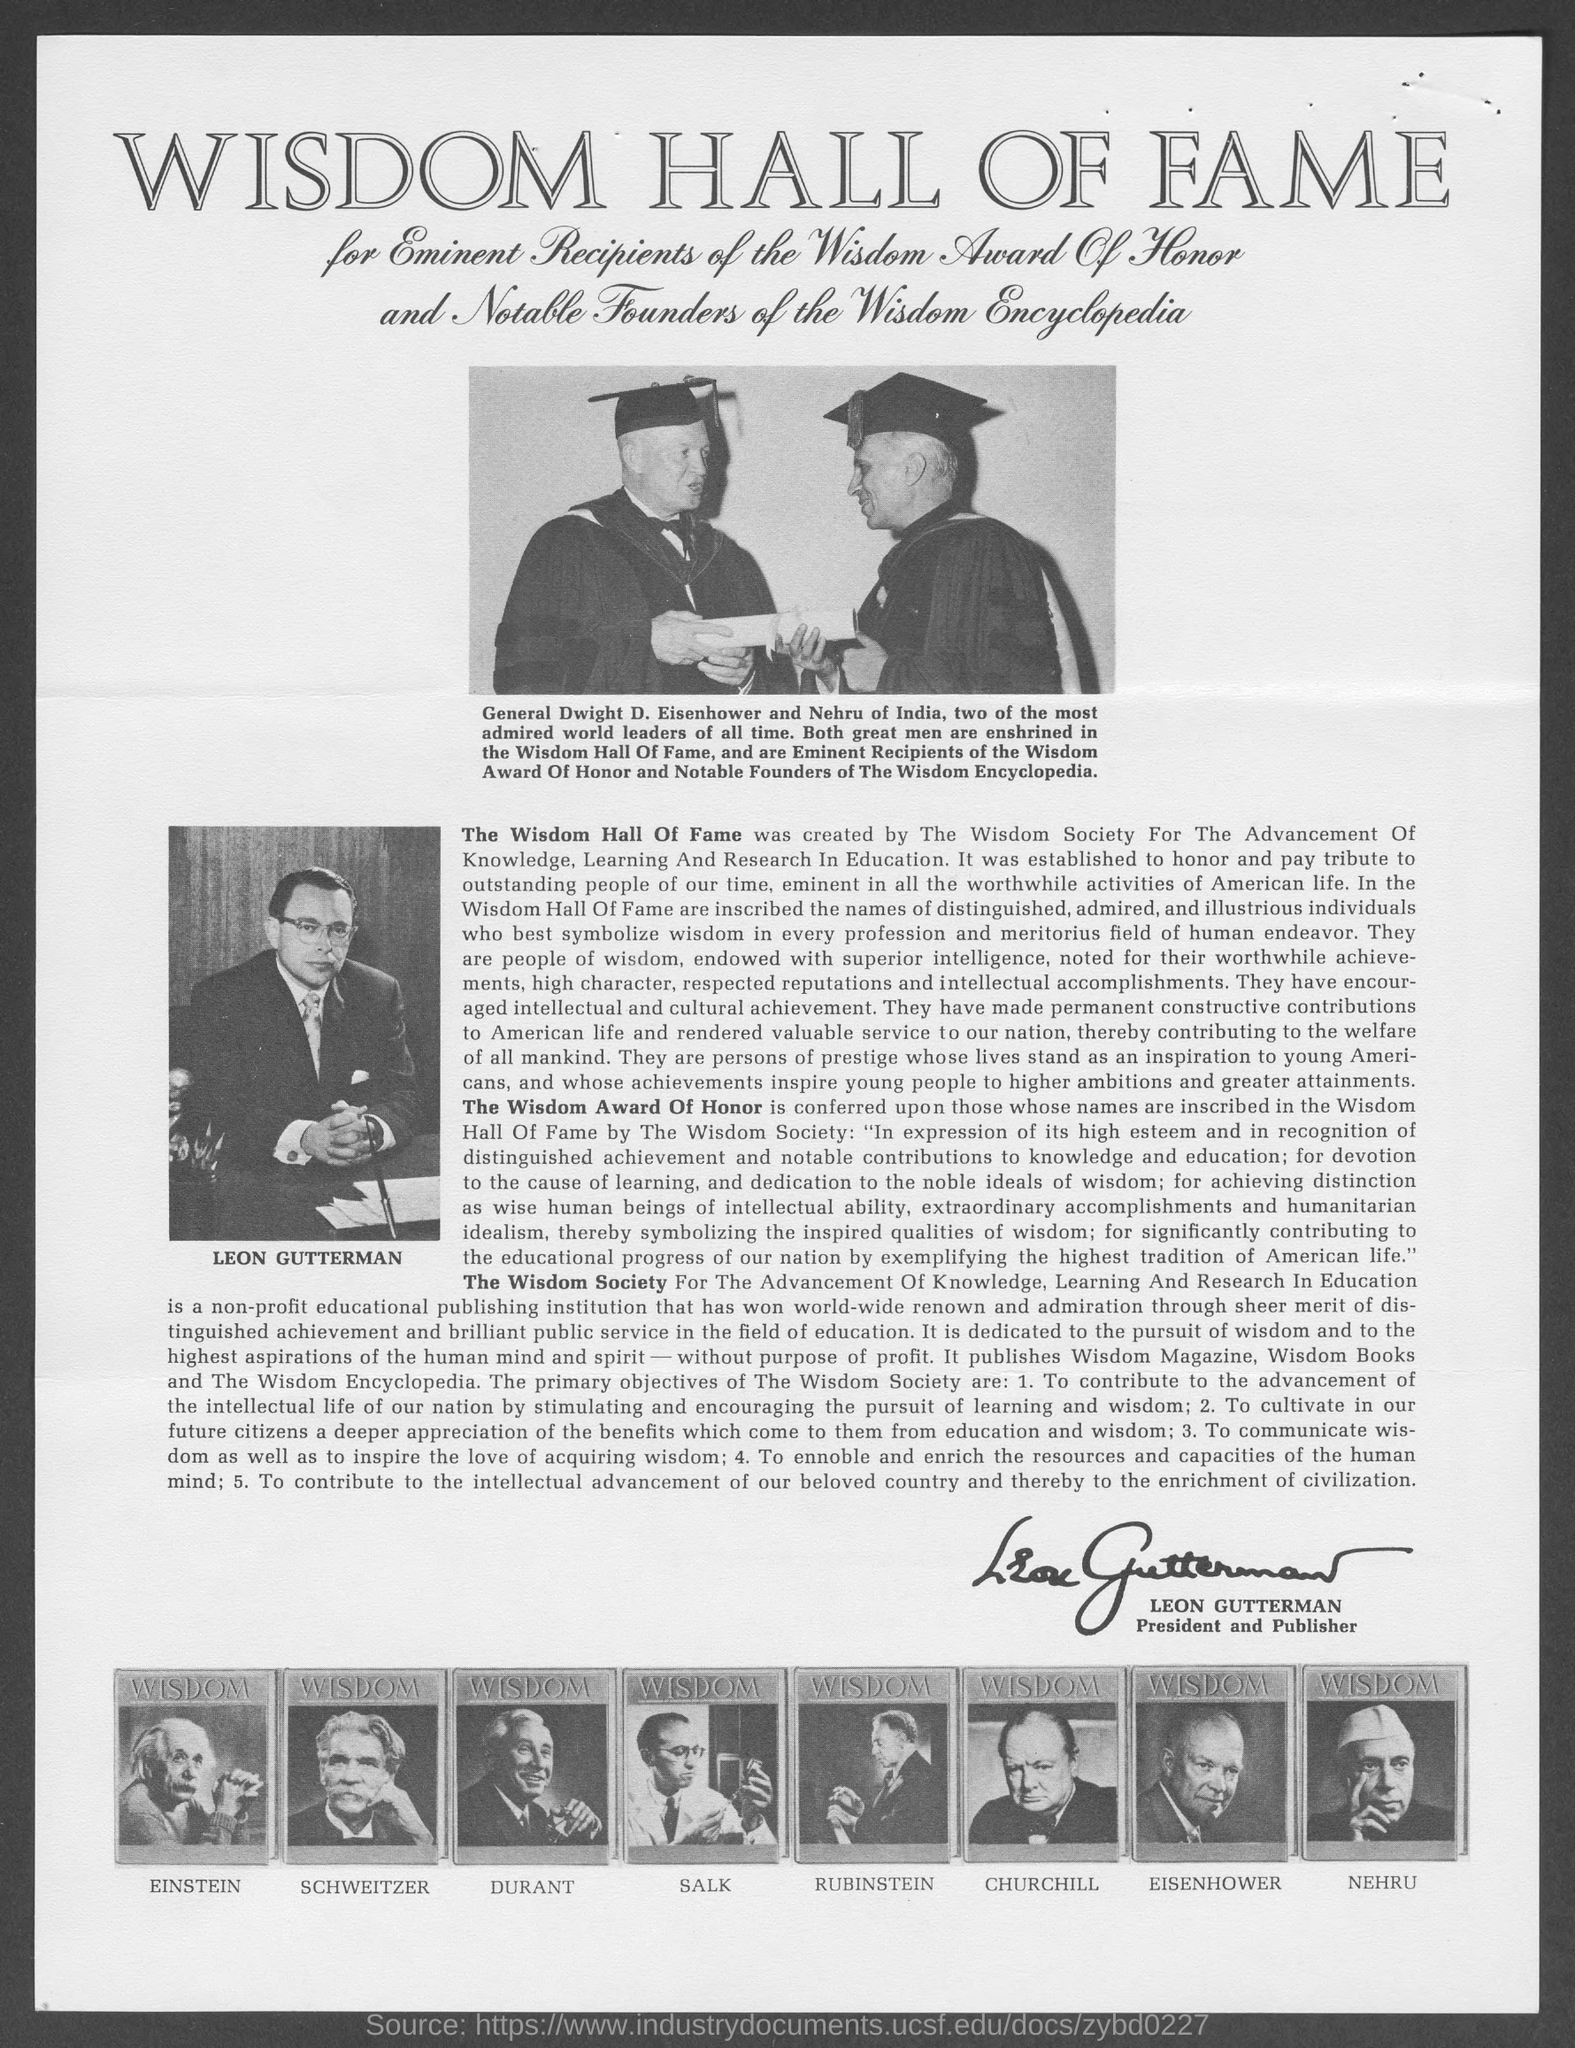Who is the president and publisher of the wisdom society?
Ensure brevity in your answer.  Leon Gutterman. Who has signed the document?
Provide a succinct answer. President and Publisher. Who appears in the photograph at the top of the document standing along with Nehru?
Make the answer very short. General Dwight D. Eisenhower. What is the name of the award mentioned in this document?
Offer a very short reply. The Wisdom Award of Honor. Whose picture comes first in the row of photos given at the bottom of the document?
Provide a succinct answer. Einstein. What is the heading of this document?
Your response must be concise. Wisdom Hall of Fame. 